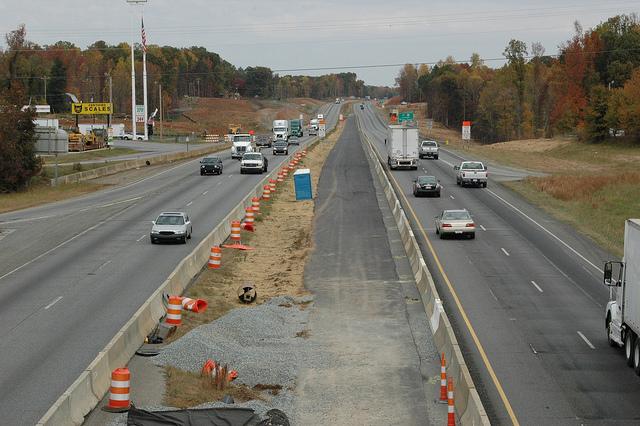What is the blue thing in between the two roads?
Concise answer only. Port-a-potty. What are they fixing in the middle?
Write a very short answer. Road. How many cars are in this picture?
Be succinct. 8. How many switchbacks are in the picture?
Short answer required. 0. 